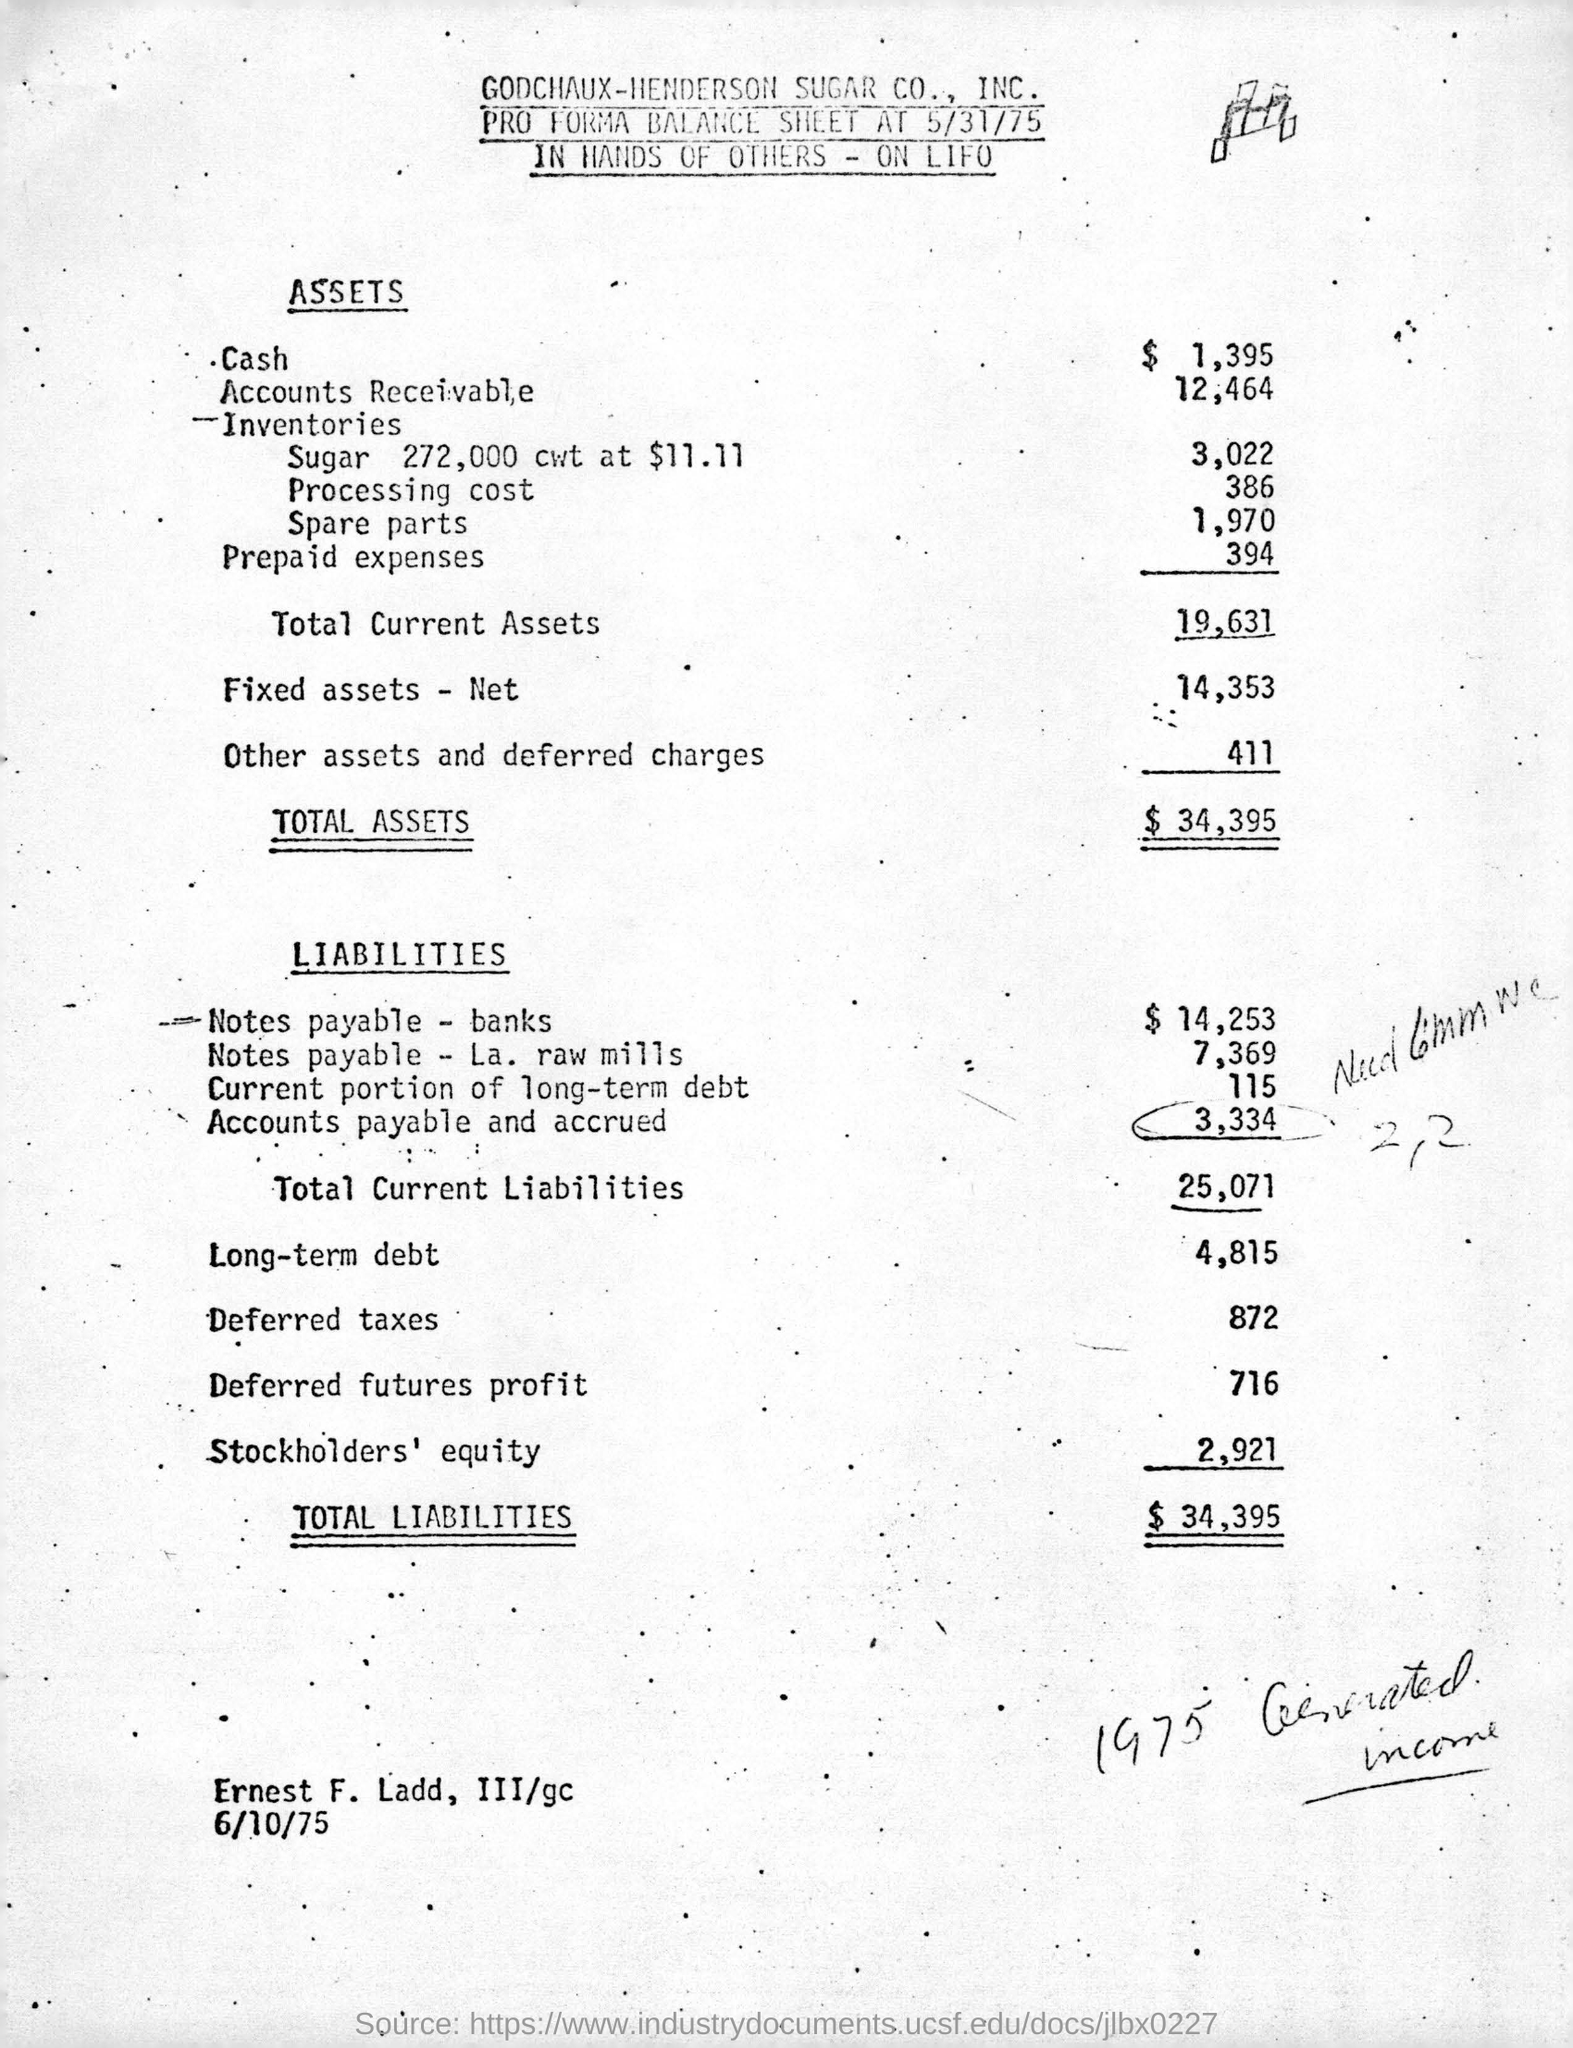Which company's balance sheet is given here?
Give a very brief answer. GODCHAUX-HENDERSON SUGAR CO., INC. What is total assets in dollars?
Your answer should be compact. 34,935. How much is total current liabilities?
Your answer should be compact. 25,071. 